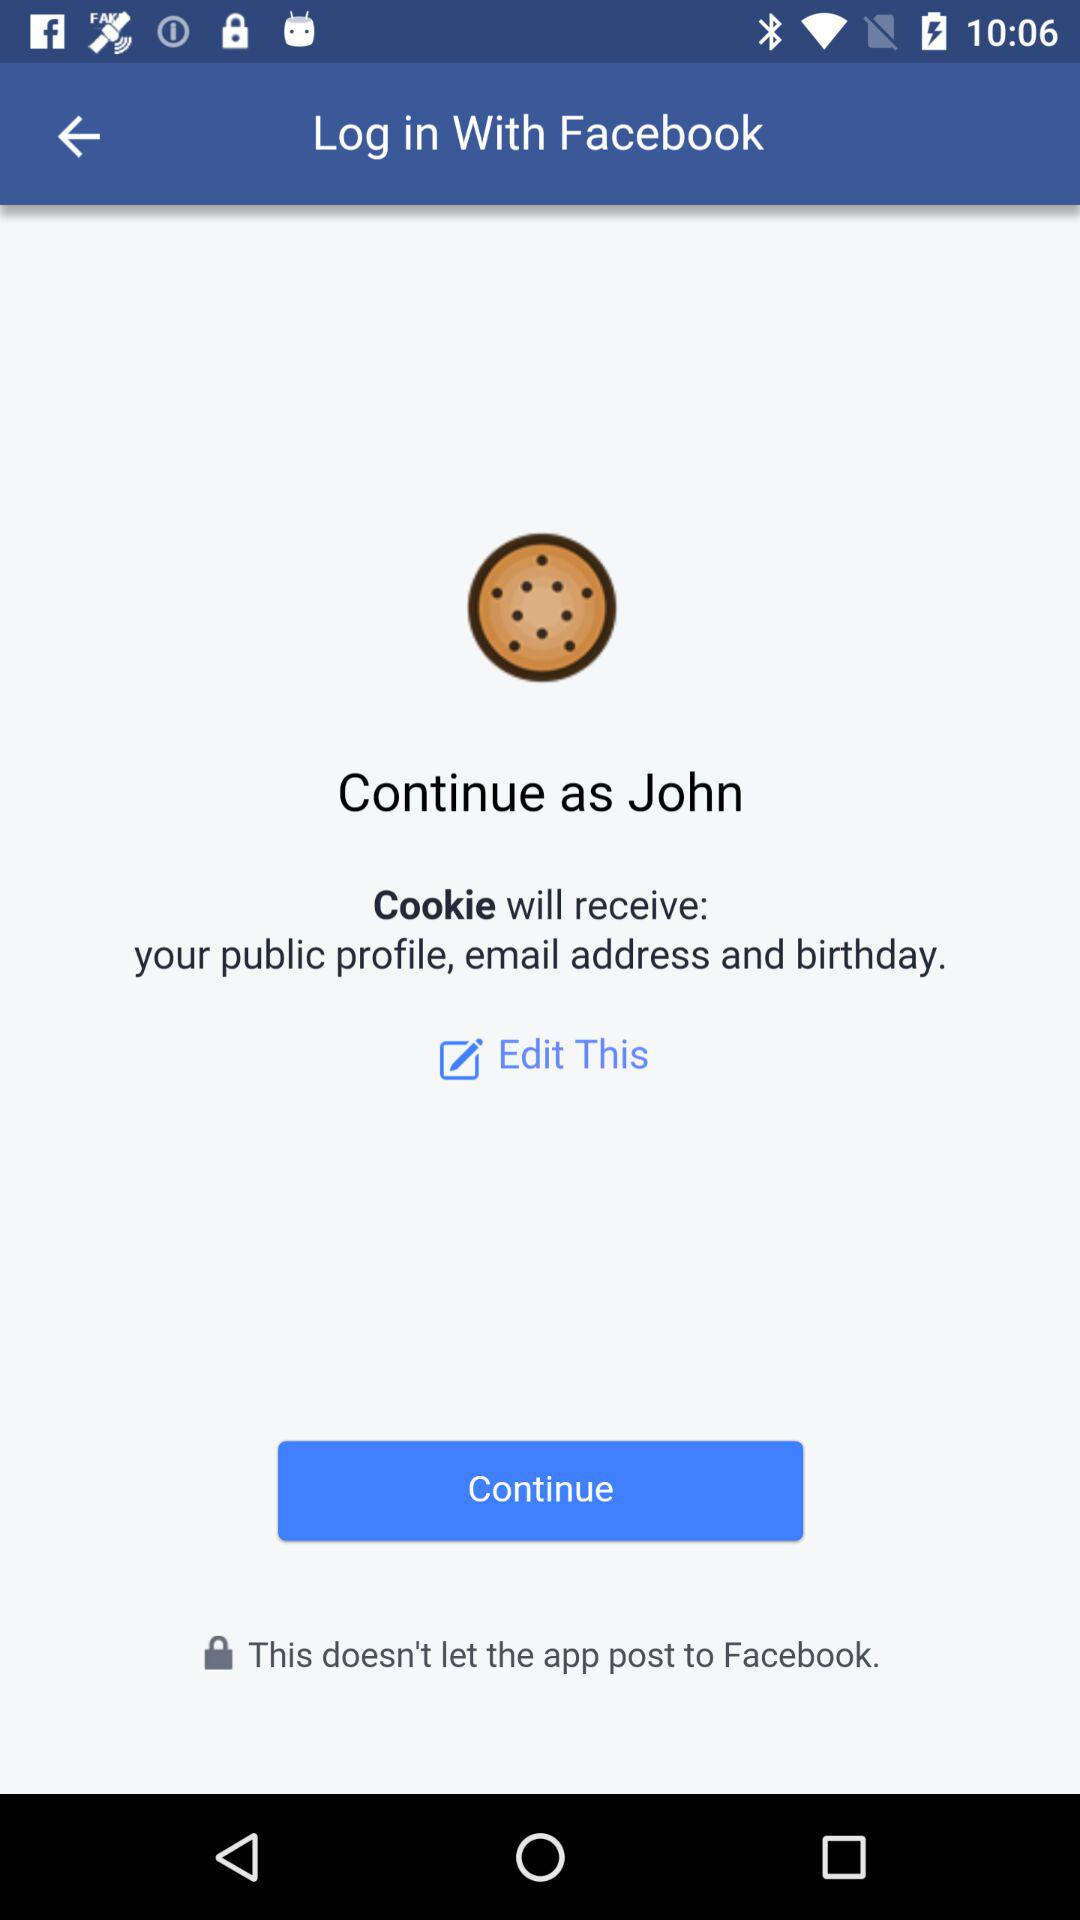What is the name of the user? The name of the user is John. 